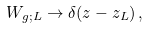Convert formula to latex. <formula><loc_0><loc_0><loc_500><loc_500>W _ { g ; L } \rightarrow \delta ( z - z _ { L } ) \, ,</formula> 